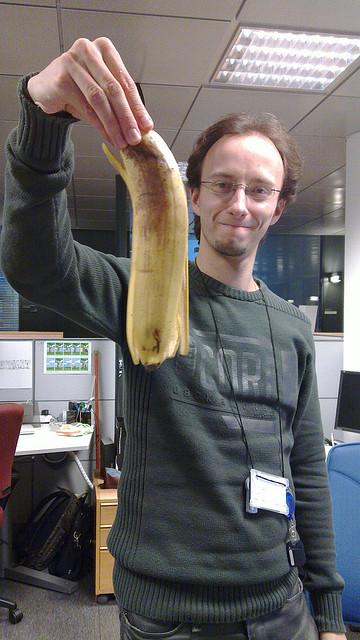What is around his neck?
Concise answer only. Name tag. Is the man holding something?
Quick response, please. Yes. Is anyone in this photo wearing glasses?
Be succinct. Yes. 